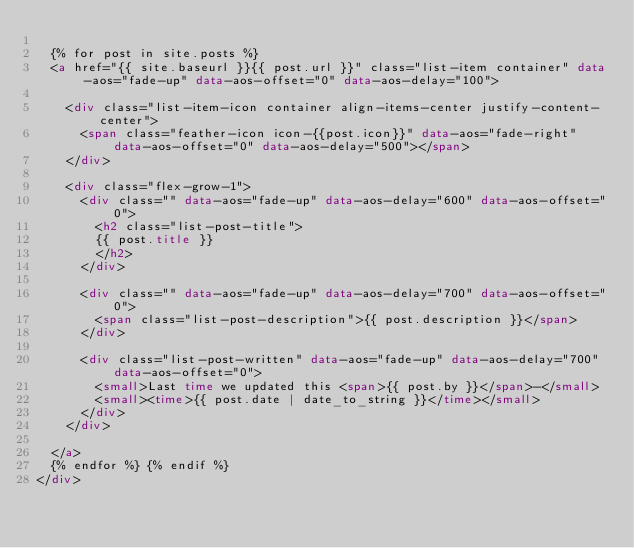Convert code to text. <code><loc_0><loc_0><loc_500><loc_500><_HTML_>
  {% for post in site.posts %}
  <a href="{{ site.baseurl }}{{ post.url }}" class="list-item container" data-aos="fade-up" data-aos-offset="0" data-aos-delay="100">

    <div class="list-item-icon container align-items-center justify-content-center">
      <span class="feather-icon icon-{{post.icon}}" data-aos="fade-right" data-aos-offset="0" data-aos-delay="500"></span>
    </div>

    <div class="flex-grow-1">
      <div class="" data-aos="fade-up" data-aos-delay="600" data-aos-offset="0">
        <h2 class="list-post-title">
        {{ post.title }}
        </h2>
      </div>

      <div class="" data-aos="fade-up" data-aos-delay="700" data-aos-offset="0">
        <span class="list-post-description">{{ post.description }}</span>
      </div>

      <div class="list-post-written" data-aos="fade-up" data-aos-delay="700" data-aos-offset="0">
        <small>Last time we updated this <span>{{ post.by }}</span>-</small>
        <small><time>{{ post.date | date_to_string }}</time></small>
      </div>
    </div>

  </a>
  {% endfor %} {% endif %}
</div>
</code> 